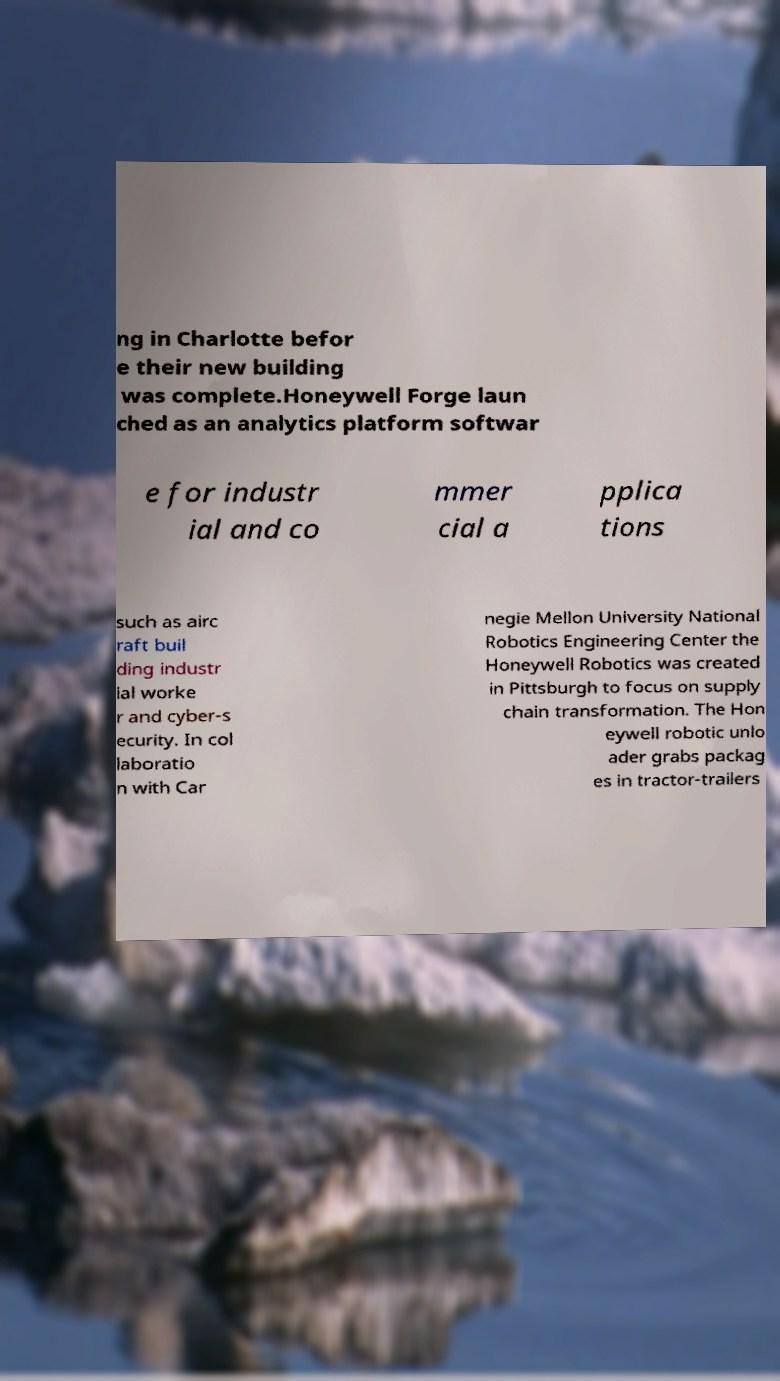Could you assist in decoding the text presented in this image and type it out clearly? ng in Charlotte befor e their new building was complete.Honeywell Forge laun ched as an analytics platform softwar e for industr ial and co mmer cial a pplica tions such as airc raft buil ding industr ial worke r and cyber-s ecurity. In col laboratio n with Car negie Mellon University National Robotics Engineering Center the Honeywell Robotics was created in Pittsburgh to focus on supply chain transformation. The Hon eywell robotic unlo ader grabs packag es in tractor-trailers 